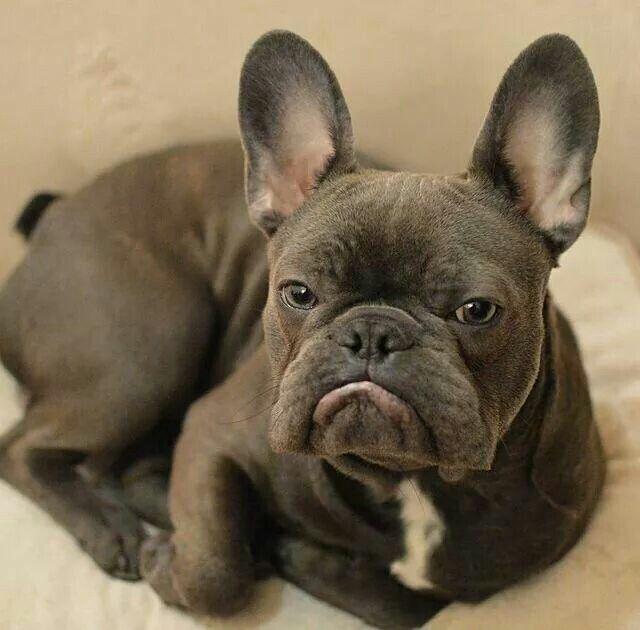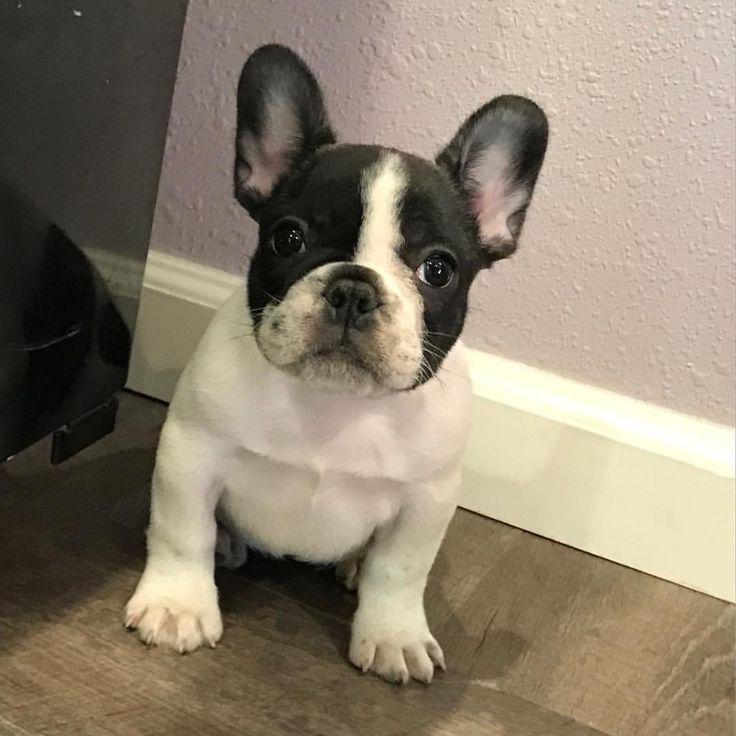The first image is the image on the left, the second image is the image on the right. For the images displayed, is the sentence "A dog is wearing a collar." factually correct? Answer yes or no. No. 